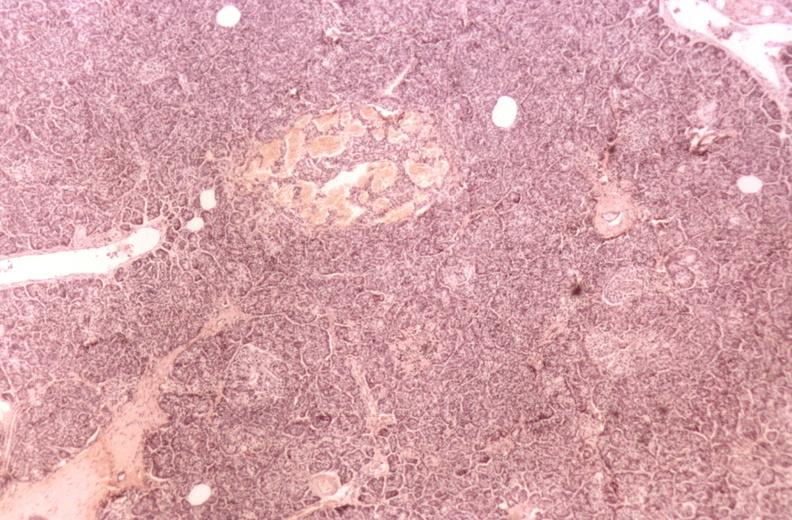does this image show kidney, glomerular amyloid, diabetes mellitus?
Answer the question using a single word or phrase. Yes 